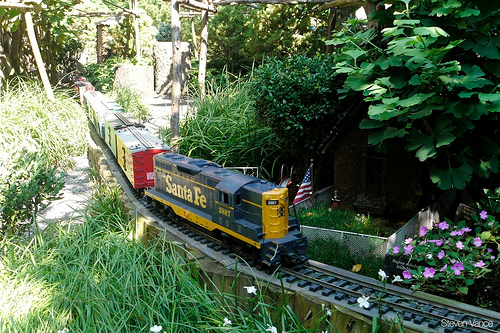Please provide a short description for this region: [0.64, 0.35, 0.83, 0.58]. The region shows a small house discreetly nestled among the bushes. 